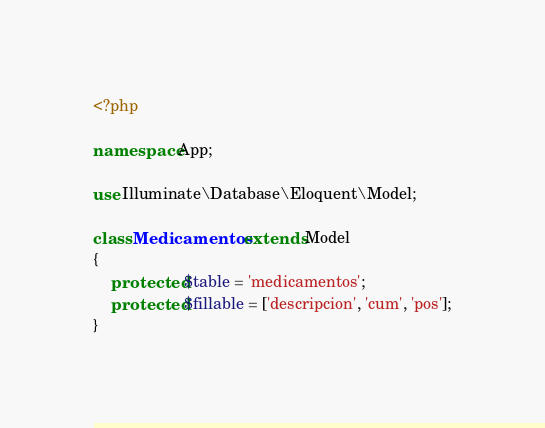Convert code to text. <code><loc_0><loc_0><loc_500><loc_500><_PHP_><?php

namespace App;

use Illuminate\Database\Eloquent\Model;

class Medicamentos extends Model
{
    protected $table = 'medicamentos';
    protected $fillable = ['descripcion', 'cum', 'pos'];
}
</code> 